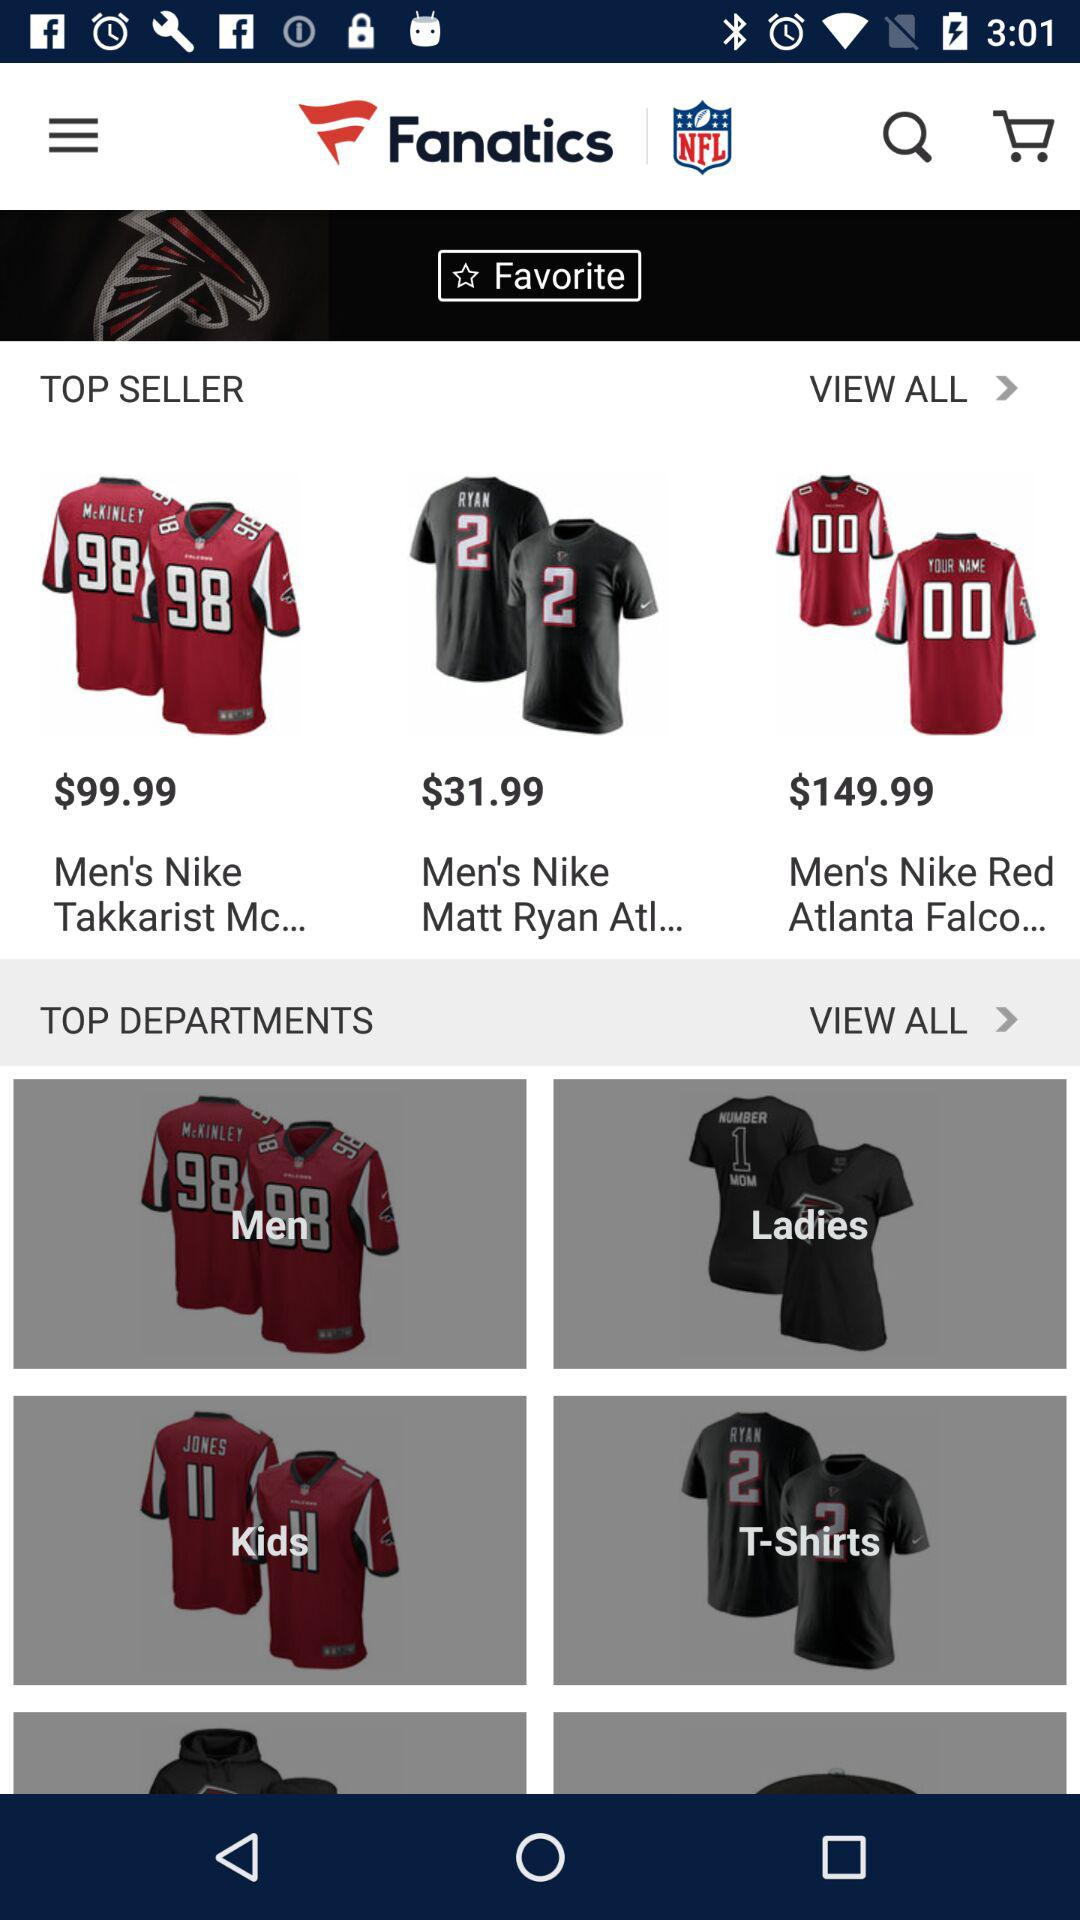How many items are in the Top Sellers section?
Answer the question using a single word or phrase. 3 